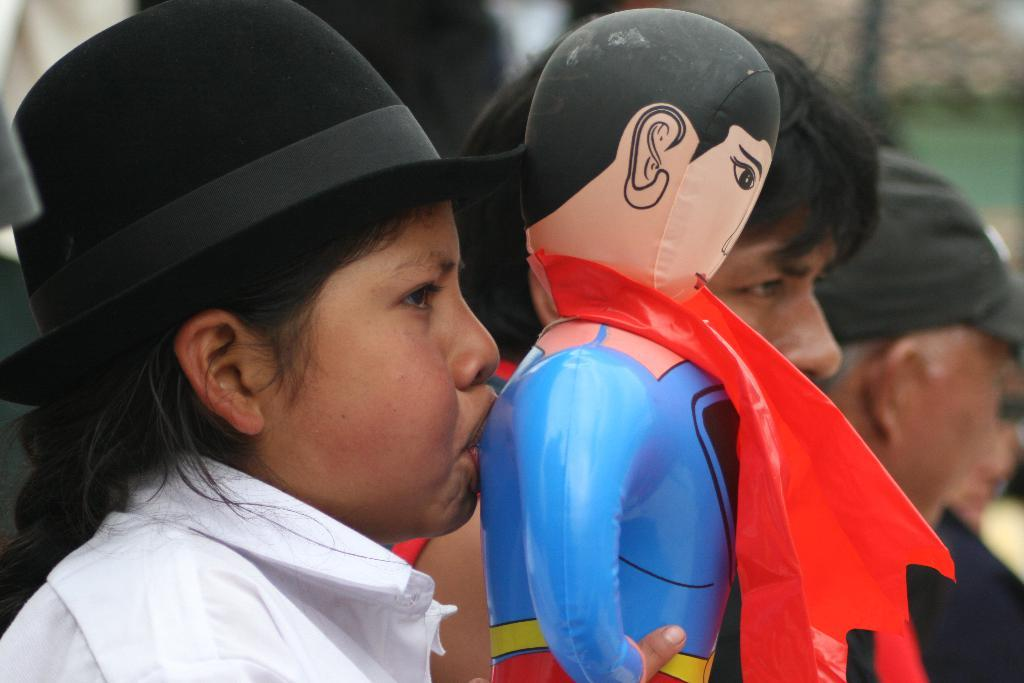Who is the main subject in the image? There is a girl in the image. Where is the girl located in the image? The girl is on the left side of the image. What is the girl holding in the image? The girl is holding a toy Spider-Man. Can you describe the background of the image? There are other people in the background of the image. What type of square can be seen in the image? There is no square present in the image. What thrilling activity is the girl participating in the image? The image does not depict any specific activity, and there is no indication of a thrilling activity. 